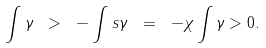Convert formula to latex. <formula><loc_0><loc_0><loc_500><loc_500>\int \gamma \ > \ - \int s \gamma \ = \ - \chi \int \gamma > 0 .</formula> 